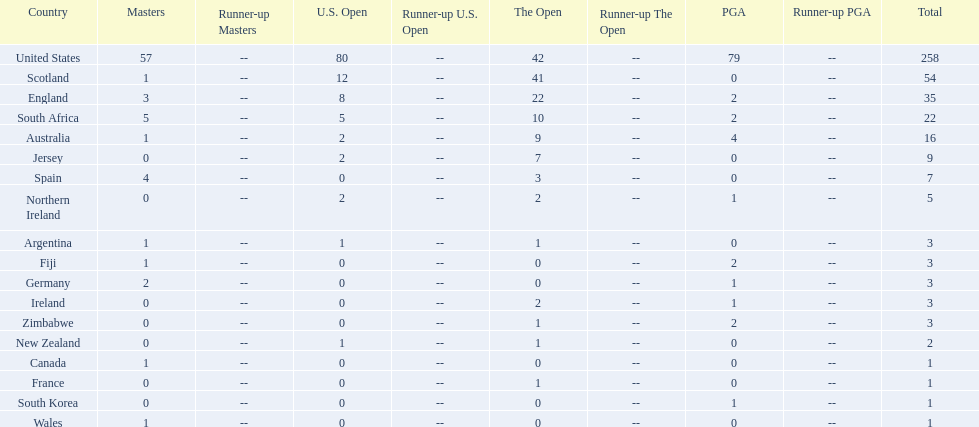What countries in the championship were from africa? South Africa, Zimbabwe. Which of these counteries had the least championship golfers Zimbabwe. 